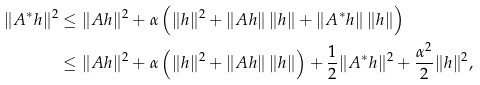Convert formula to latex. <formula><loc_0><loc_0><loc_500><loc_500>\| A ^ { * } h \| ^ { 2 } & \leq \| A h \| ^ { 2 } + \alpha \left ( \| h \| ^ { 2 } + \| A h \| \, \| h \| + \| A ^ { * } h \| \, \| h \| \right ) \\ & \leq \| A h \| ^ { 2 } + \alpha \left ( \| h \| ^ { 2 } + \| A h \| \, \| h \| \right ) + \frac { 1 } { 2 } \| A ^ { * } h \| ^ { 2 } + \frac { \alpha ^ { 2 } } { 2 } \| h \| ^ { 2 } ,</formula> 